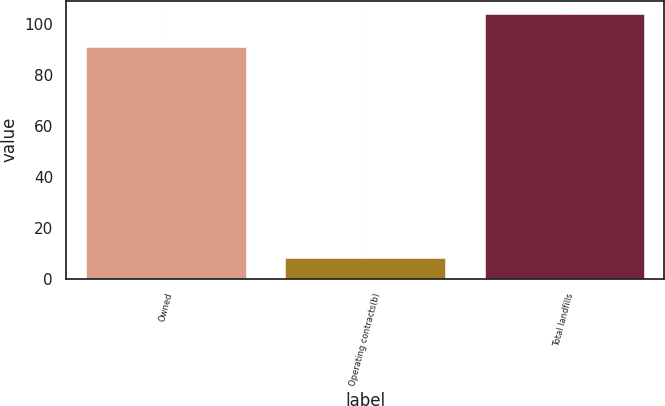<chart> <loc_0><loc_0><loc_500><loc_500><bar_chart><fcel>Owned<fcel>Operating contracts(b)<fcel>Total landfills<nl><fcel>91<fcel>8<fcel>104<nl></chart> 